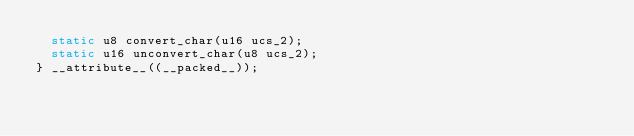Convert code to text. <code><loc_0><loc_0><loc_500><loc_500><_C++_>  static u8 convert_char(u16 ucs_2);
  static u16 unconvert_char(u8 ucs_2);
} __attribute__((__packed__));
</code> 